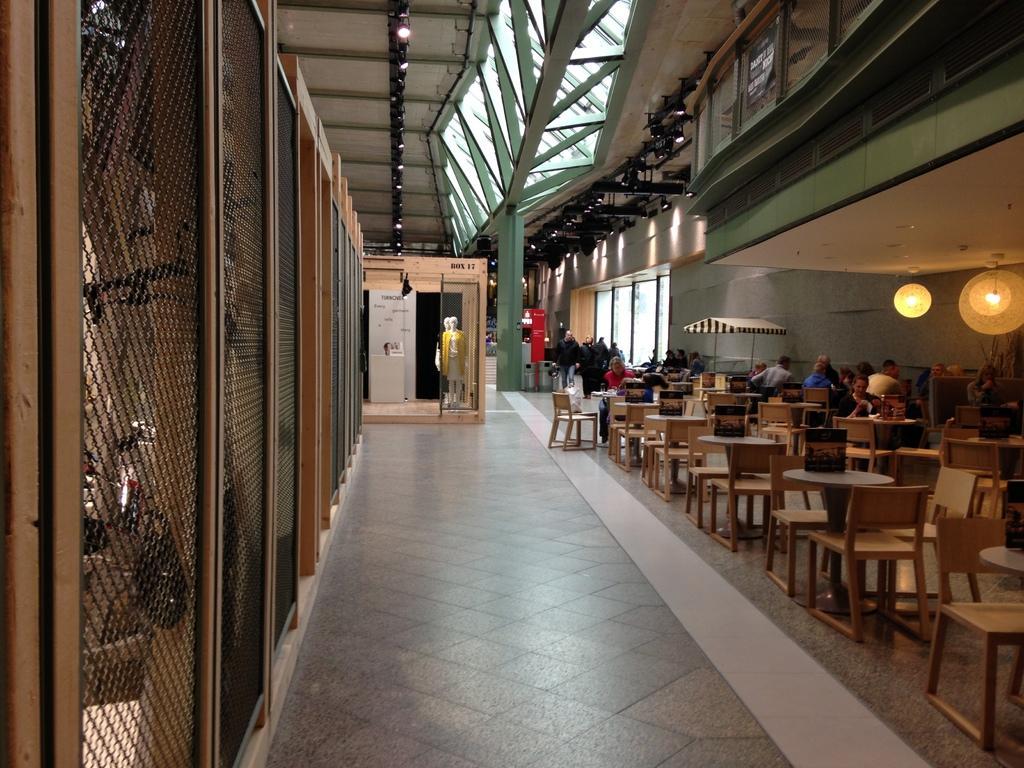Can you describe this image briefly? In the foreground of this image, there is the floor. On the left, there is the mesh. On the right, there are tables, chairs, lights, persons sitting on the chairs and a tent. In the background, there are persons, glass window, mannequin and the ceiling on the top. 